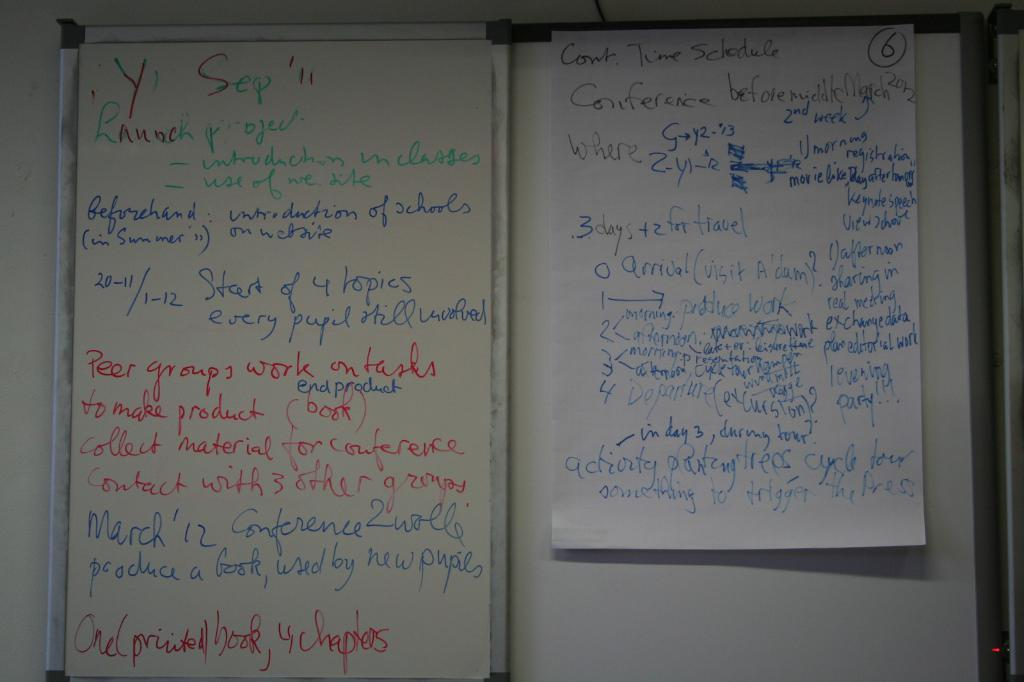<image>
Describe the image concisely. A whiteboard has details about a launch project scribbled all over it in different colors. 